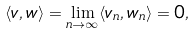Convert formula to latex. <formula><loc_0><loc_0><loc_500><loc_500>\langle v , w \rangle = \lim _ { n \to \infty } \langle v _ { n } , w _ { n } \rangle = 0 ,</formula> 